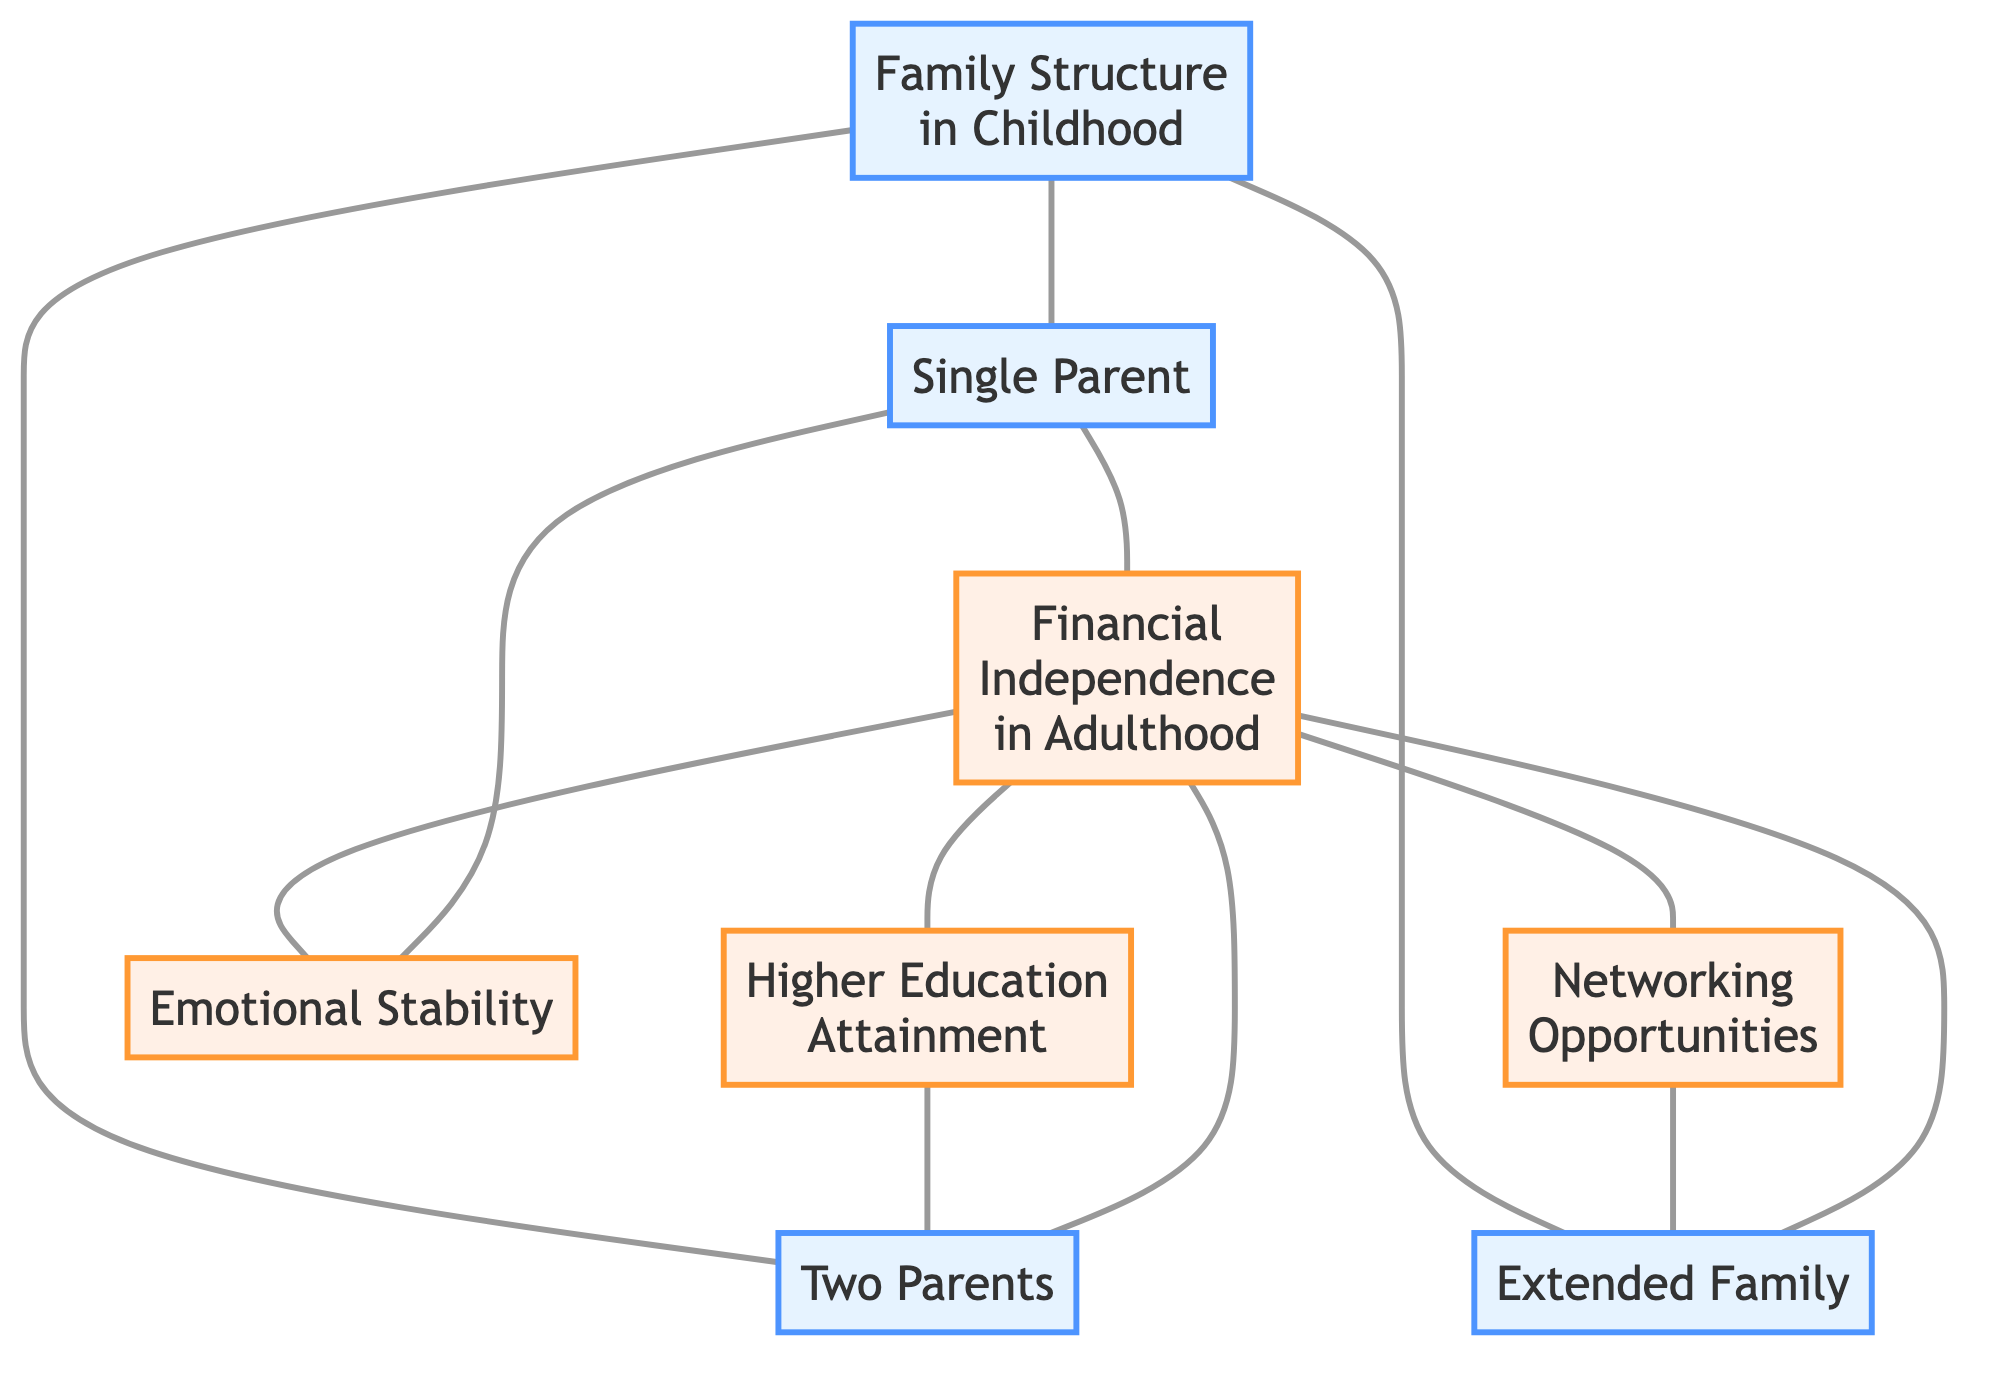What are the three types of family structure in childhood indicated in the diagram? The diagram clearly shows three types of family structures connected to the node "Family Structure in Childhood": Single Parent, Two Parents, and Extended Family.
Answer: Single Parent, Two Parents, Extended Family How many nodes are there in this diagram? By counting the nodes listed, we see there are eight distinct nodes: Family Structure in Childhood, Single Parent, Two Parents, Extended Family, Financial Independence in Adulthood, Higher Education Attainment, Emotional Stability, and Networking Opportunities.
Answer: Eight What is the relationship between "Single Parent" and "Financial Independence in Adulthood"? The diagram illustrates a link between "Single Parent" and "Financial Independence in Adulthood," indicating that this family structure has a direct connection to financial outcomes in adulthood.
Answer: Direct connection Which family structure is linked to "Higher Education Attainment"? The diagram shows that "Higher Education Attainment" is linked to "Financial Independence in Adulthood," and through reasoning, it's also connected indirectly to "Two Parents," hence inferring that "Higher Education Attainment" is influenced by those from a "Two Parents" structure.
Answer: Two Parents What influences "Emotional Stability" based on the diagram? "Emotional Stability" is influenced directly by the "Single Parent" structure as indicated by the link in the diagram. Therefore, it suggests that individuals from a single-parent family may experience specific emotional outcomes connected to their family dynamics.
Answer: Single Parent How many connections are there from "Financial Independence in Adulthood"? By examining the diagram, we see "Financial Independence in Adulthood" connects to three nodes: Higher Education Attainment, Emotional Stability, and Networking Opportunities, making a total of three connections.
Answer: Three Which type of family structure is most directly associated with "Networking Opportunities"? The diagram shows a direct connection between "Networking Opportunities" and "Extended Family," indicating that individuals raised in extended family settings may have better networking possibilities.
Answer: Extended Family What is the indirect influence of "Single Parent" structure on adult success? "Single Parent" is linked directly to "Financial Independence in Adulthood," which subsequently connects to "Higher Education Attainment" and "Emotional Stability." Thus, the influence is indirect through these outcomes.
Answer: Financial Independence in Adulthood How many types of financial outcomes are linked from "Financial Independence in Adulthood"? The diagram shows that "Financial Independence in Adulthood" connects to three financial outcome types: Higher Education Attainment, Emotional Stability, and Networking Opportunities, indicating multiple pathways to financial success.
Answer: Three 